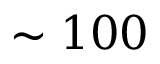<formula> <loc_0><loc_0><loc_500><loc_500>\sim 1 0 0</formula> 